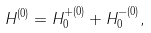<formula> <loc_0><loc_0><loc_500><loc_500>H ^ { ( 0 ) } = H ^ { + ( 0 ) } _ { 0 } + H ^ { - ( 0 ) } _ { 0 } ,</formula> 